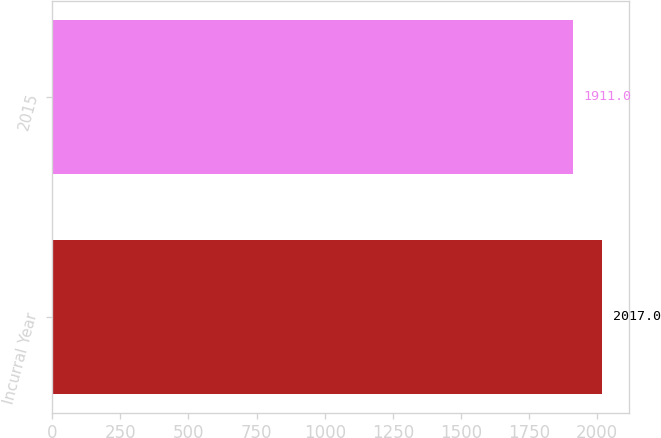Convert chart to OTSL. <chart><loc_0><loc_0><loc_500><loc_500><bar_chart><fcel>Incurral Year<fcel>2015<nl><fcel>2017<fcel>1911<nl></chart> 